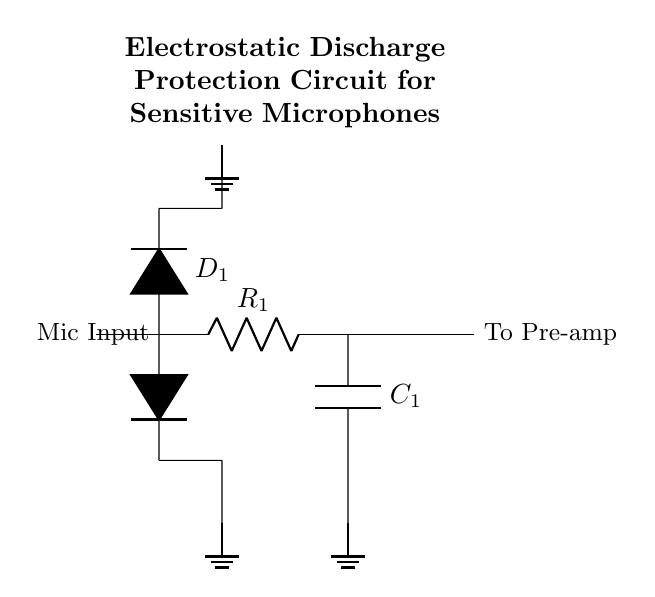What is the purpose of diode D1? Diode D1 is an electrostatic discharge protection component that allows current to flow in a forward direction to ground when an over-voltage occurs, thus protecting the sensitive microphone circuitry from potential damage.
Answer: Electrostatic discharge protection What type of component is R1? R1 is a resistor, which serves to limit the current flowing into the microphone input, helping to protect against excessive current that can cause damage.
Answer: Resistor How many diodes are used in this circuit? There are two diodes, D1 and D2, both providing electrostatic discharge protection by shunting excess voltage to ground.
Answer: Two What is the connection of capacitor C1? Capacitor C1 is connected to ground, providing filtering for high-frequency noise and helping to stabilize the voltage at the microphone input.
Answer: Ground Which component connects the microphone input to the pre-amplifier? The circuit connection from the output node at point 4 to the "To Pre-amp" label signifies the pathway through which the microphone signal is passed along to the pre-amplifier.
Answer: R1 Why are there ground connections in this circuit? The ground connections are essential for establishing a reference point for the circuit voltage, providing a safe path for excess energy from electrostatic discharges to dissipate.
Answer: Safe energy dissipation 